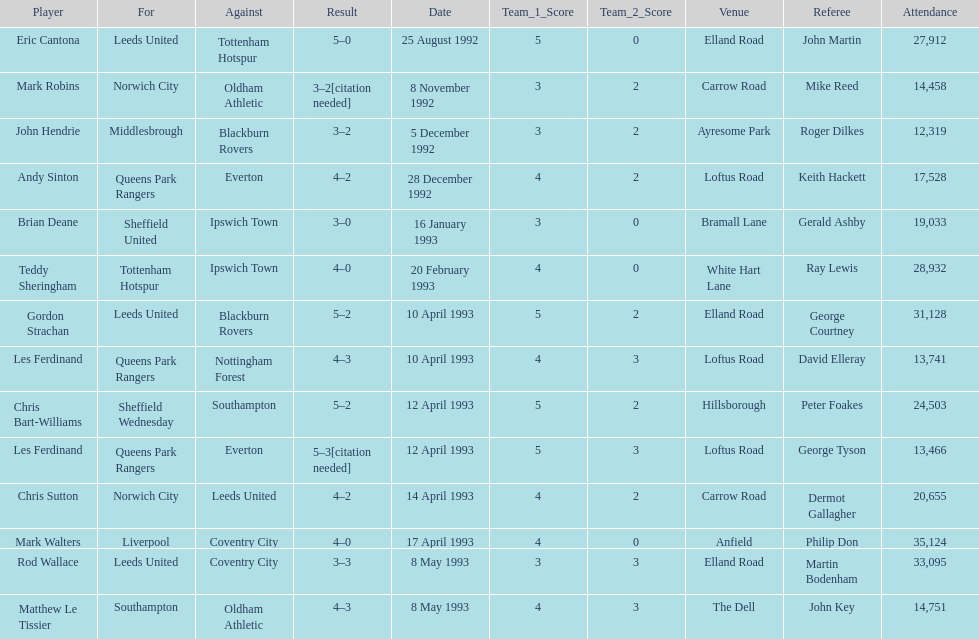Which player had the same result as mark robins? John Hendrie. 